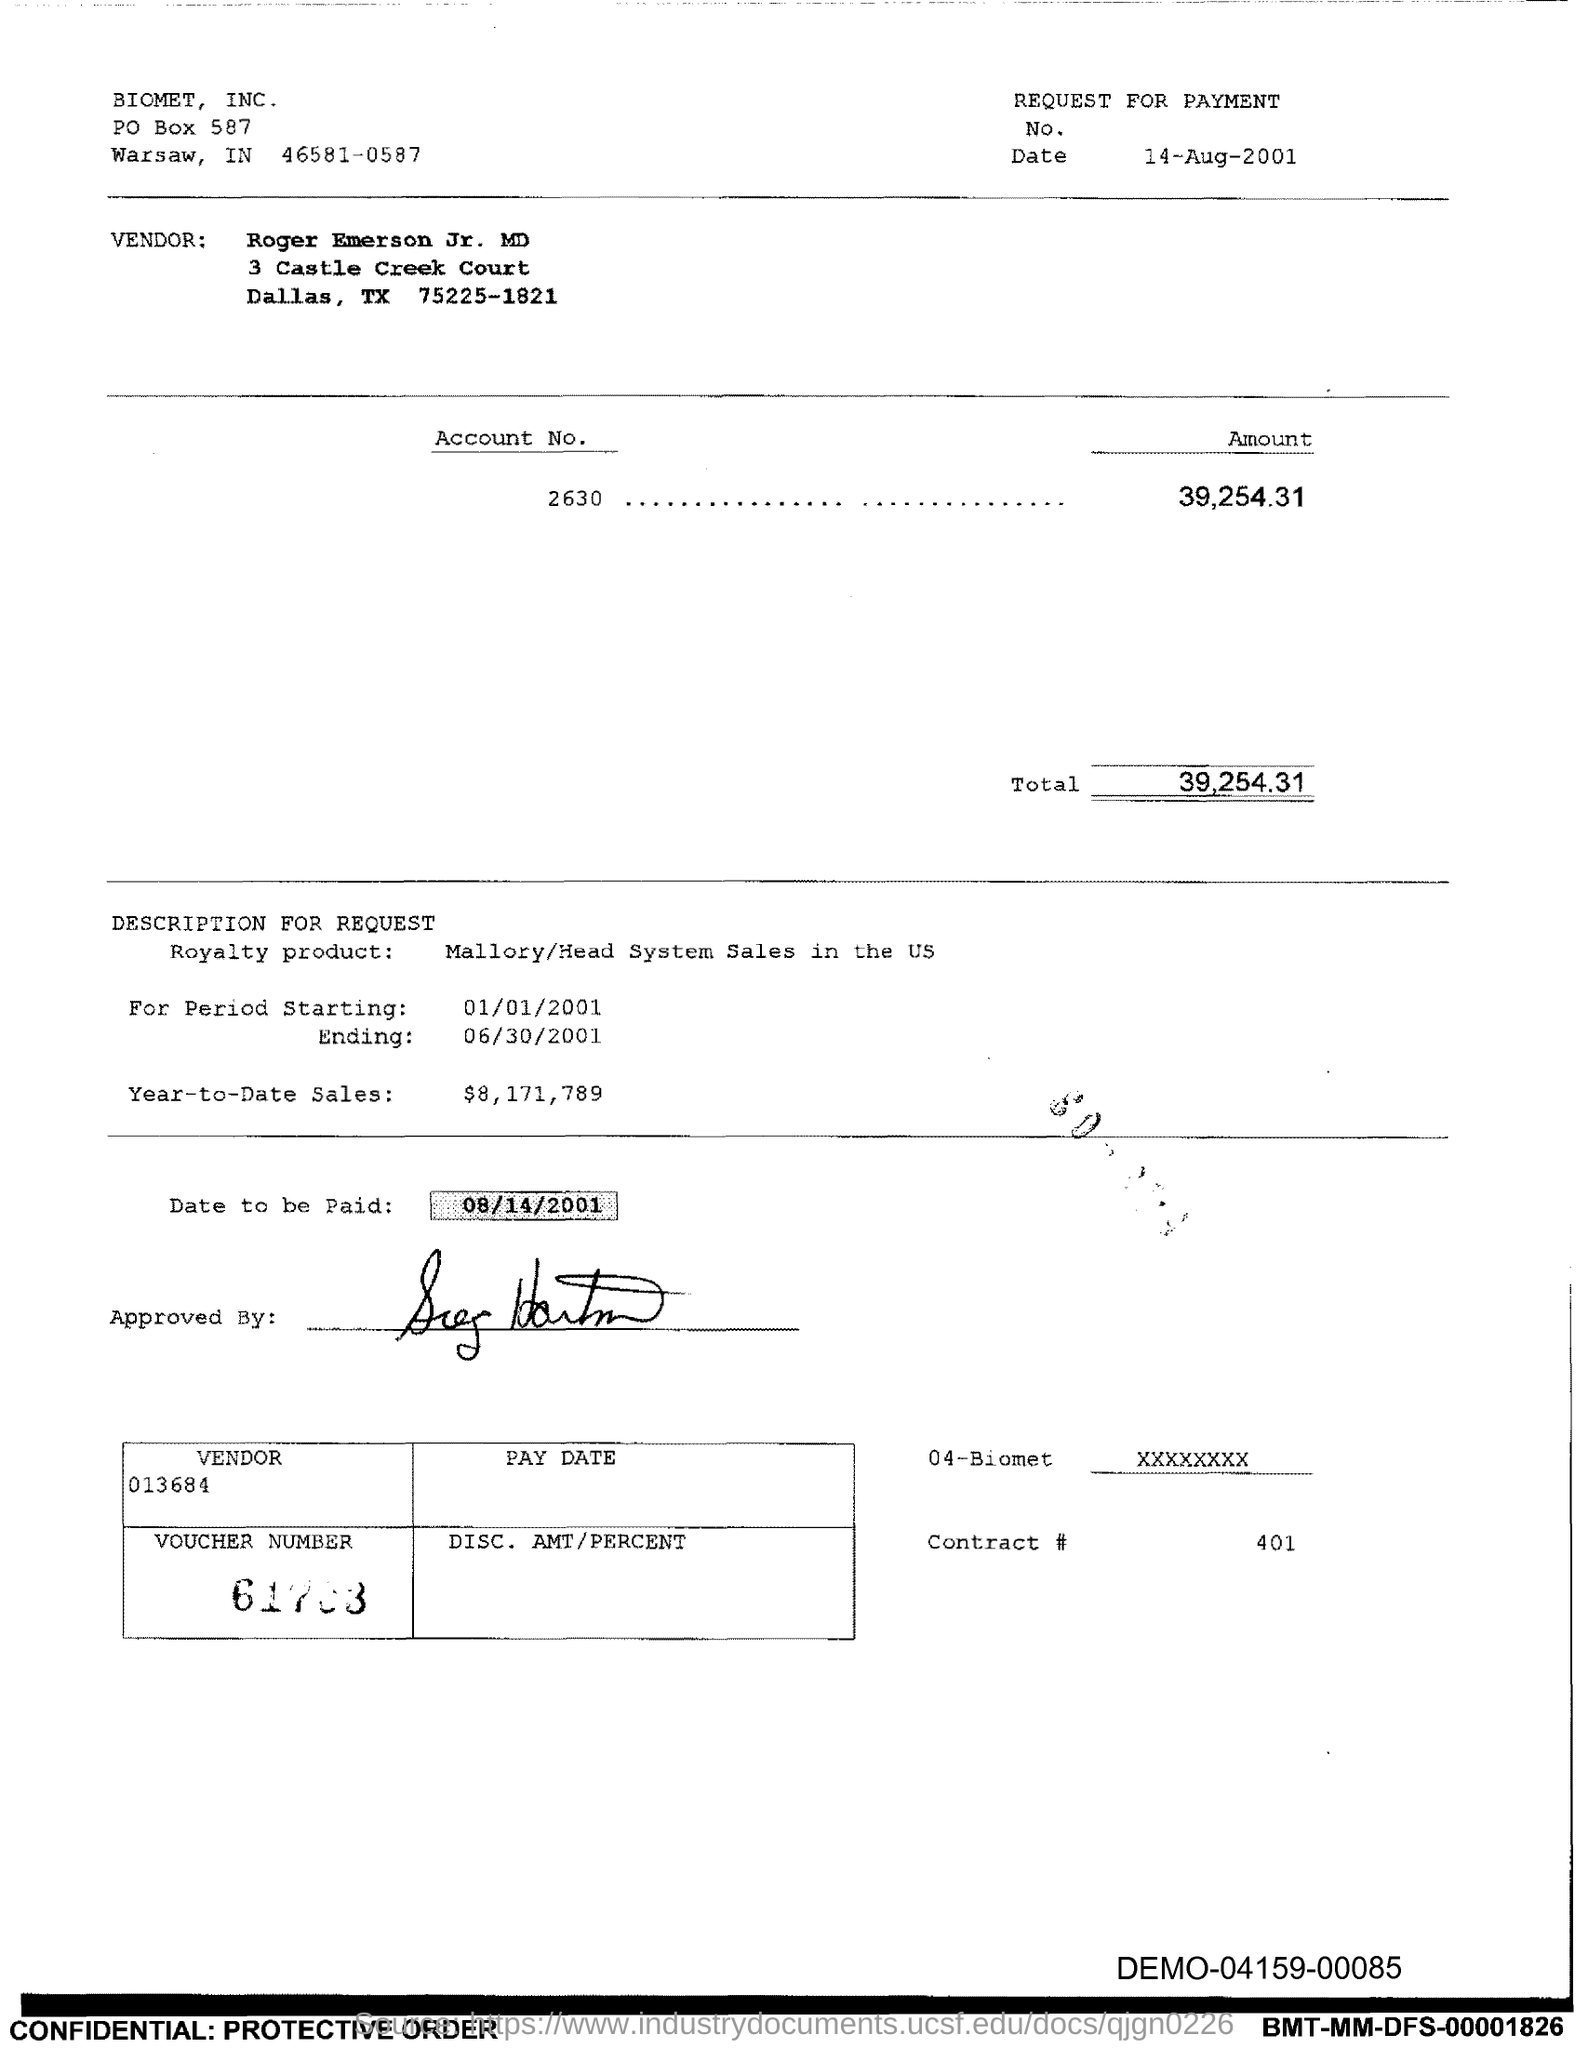What is the Date?
Provide a succinct answer. 14-aug-2001. Who is the Vendor?
Provide a succinct answer. ROGER EMERSON JR. What is the Amount?
Your response must be concise. 39,254.31. What is the Total?
Offer a terse response. 39,254.31. What is the Royalty Product?
Keep it short and to the point. Mallory/Head system sales in the US. What is the starting period?
Ensure brevity in your answer.  01/01/2001. What is the ending period?
Provide a succinct answer. 06/30/2001. What is the Year-to-date sales?
Provide a short and direct response. $8,171,789. What is the "date to be paid"?
Offer a very short reply. 08/14/2001. What is the Vendor number?
Keep it short and to the point. 013684. 